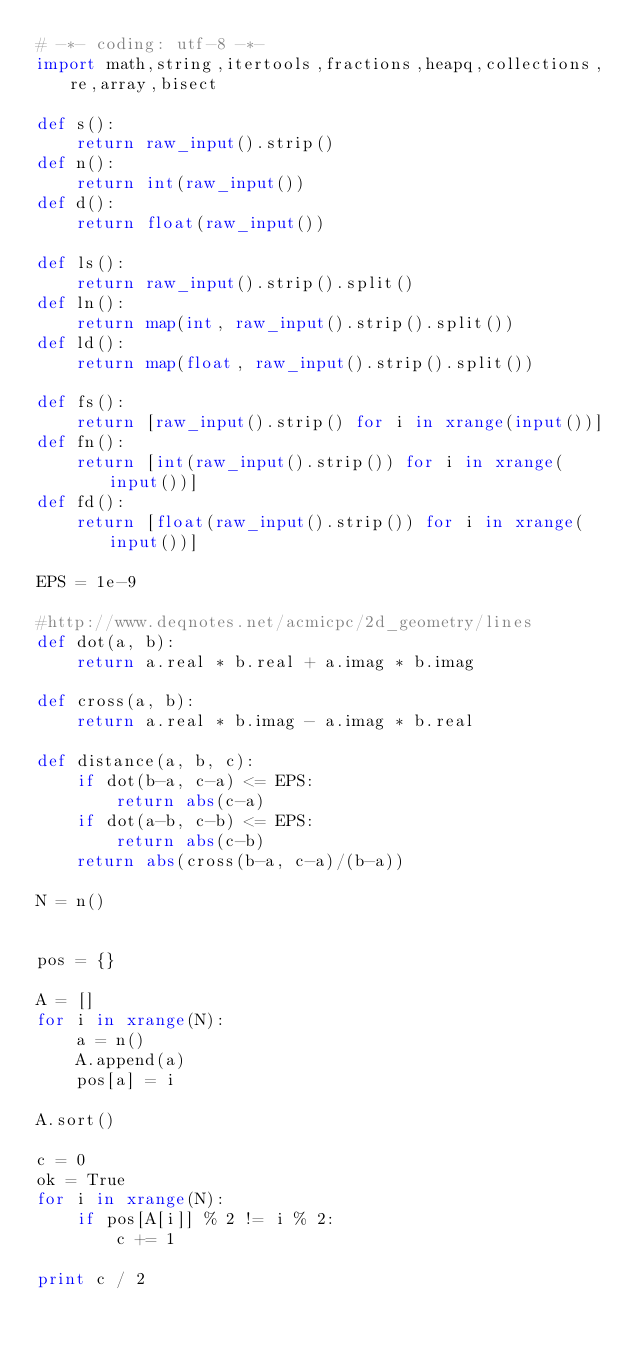<code> <loc_0><loc_0><loc_500><loc_500><_Python_># -*- coding: utf-8 -*-
import math,string,itertools,fractions,heapq,collections,re,array,bisect

def s():
    return raw_input().strip()
def n():
    return int(raw_input())
def d():
    return float(raw_input())

def ls():
    return raw_input().strip().split()
def ln():
    return map(int, raw_input().strip().split())
def ld():
    return map(float, raw_input().strip().split())

def fs():
    return [raw_input().strip() for i in xrange(input())]
def fn():
    return [int(raw_input().strip()) for i in xrange(input())]
def fd():
    return [float(raw_input().strip()) for i in xrange(input())]

EPS = 1e-9

#http://www.deqnotes.net/acmicpc/2d_geometry/lines
def dot(a, b):
    return a.real * b.real + a.imag * b.imag

def cross(a, b):
    return a.real * b.imag - a.imag * b.real

def distance(a, b, c):
    if dot(b-a, c-a) <= EPS:
        return abs(c-a)
    if dot(a-b, c-b) <= EPS:
        return abs(c-b)
    return abs(cross(b-a, c-a)/(b-a))

N = n()


pos = {}

A = []
for i in xrange(N):
    a = n()
    A.append(a)
    pos[a] = i

A.sort()

c = 0
ok = True
for i in xrange(N):
    if pos[A[i]] % 2 != i % 2:
        c += 1

print c / 2
</code> 